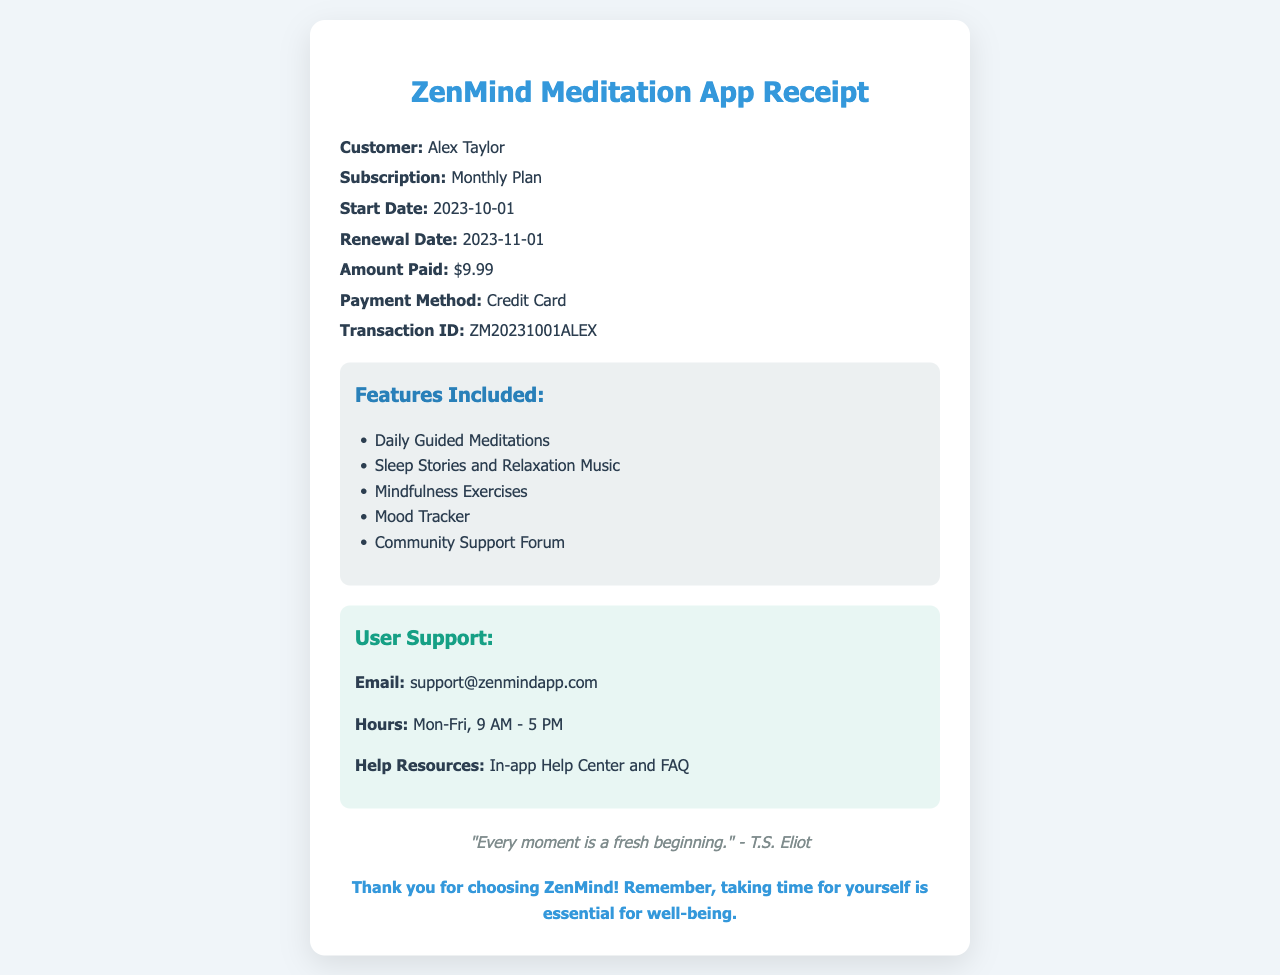What is the name of the customer? The document specifies the customer's name as Alex Taylor.
Answer: Alex Taylor What type of subscription was purchased? The receipt indicates that the subscription is a Monthly Plan.
Answer: Monthly Plan What is the amount paid for the subscription? The amount listed on the receipt for the subscription is $9.99.
Answer: $9.99 When is the renewal date for the subscription? The renewal date mentioned in the document is 2023-11-01.
Answer: 2023-11-01 What features are included in the subscription? The features listed include Daily Guided Meditations, Sleep Stories and Relaxation Music, Mindfulness Exercises, Mood Tracker, and Community Support Forum.
Answer: Daily Guided Meditations, Sleep Stories and Relaxation Music, Mindfulness Exercises, Mood Tracker, Community Support Forum What is the transaction ID for this purchase? The receipt provides the transaction ID as ZM20231001ALEX.
Answer: ZM20231001ALEX What is the support email for the app? The document lists the support email as support@zenmindapp.com.
Answer: support@zenmindapp.com What quote is included in the document? The document contains a quote by T.S. Eliot: "Every moment is a fresh beginning."
Answer: "Every moment is a fresh beginning." What is the note at the bottom of the receipt? The note encourages the user, stating that taking time for oneself is essential for well-being.
Answer: Thank you for choosing ZenMind! Remember, taking time for yourself is essential for well-being 